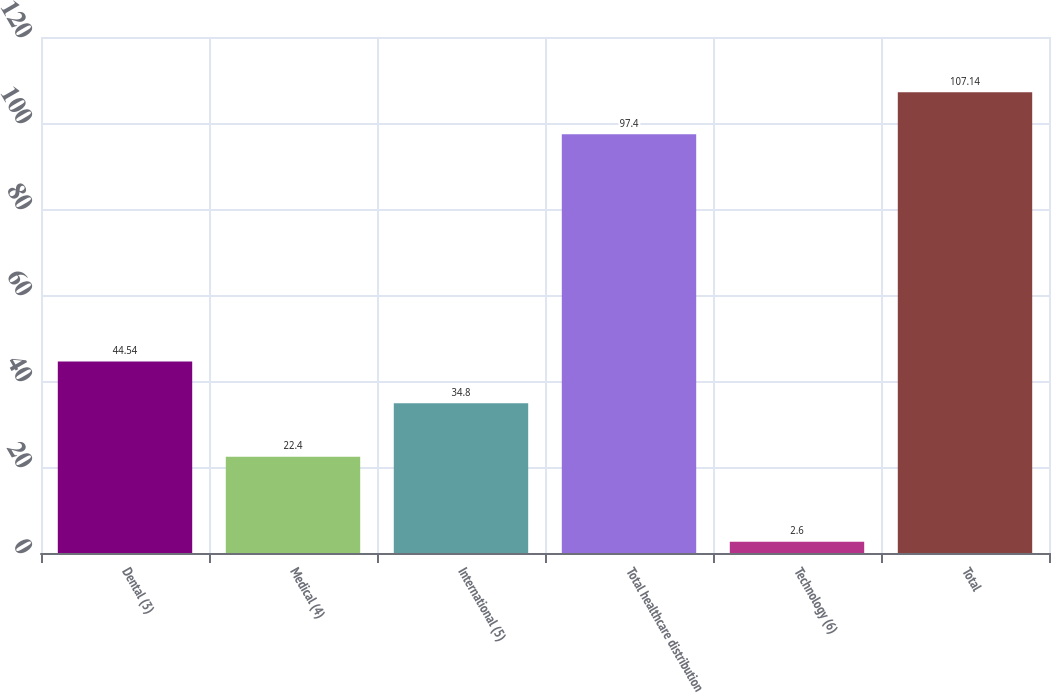Convert chart. <chart><loc_0><loc_0><loc_500><loc_500><bar_chart><fcel>Dental (3)<fcel>Medical (4)<fcel>International (5)<fcel>Total healthcare distribution<fcel>Technology (6)<fcel>Total<nl><fcel>44.54<fcel>22.4<fcel>34.8<fcel>97.4<fcel>2.6<fcel>107.14<nl></chart> 